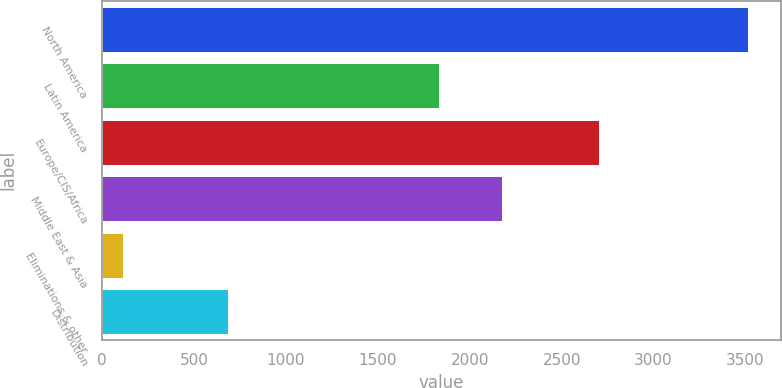<chart> <loc_0><loc_0><loc_500><loc_500><bar_chart><fcel>North America<fcel>Latin America<fcel>Europe/CIS/Africa<fcel>Middle East & Asia<fcel>Eliminations & other<fcel>Distribution<nl><fcel>3516<fcel>1834<fcel>2704<fcel>2174.4<fcel>112<fcel>685<nl></chart> 